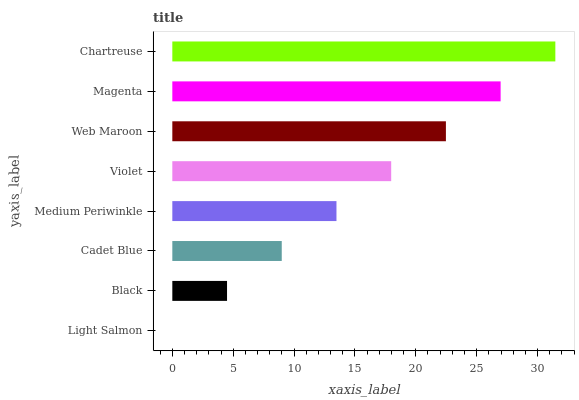Is Light Salmon the minimum?
Answer yes or no. Yes. Is Chartreuse the maximum?
Answer yes or no. Yes. Is Black the minimum?
Answer yes or no. No. Is Black the maximum?
Answer yes or no. No. Is Black greater than Light Salmon?
Answer yes or no. Yes. Is Light Salmon less than Black?
Answer yes or no. Yes. Is Light Salmon greater than Black?
Answer yes or no. No. Is Black less than Light Salmon?
Answer yes or no. No. Is Violet the high median?
Answer yes or no. Yes. Is Medium Periwinkle the low median?
Answer yes or no. Yes. Is Web Maroon the high median?
Answer yes or no. No. Is Chartreuse the low median?
Answer yes or no. No. 